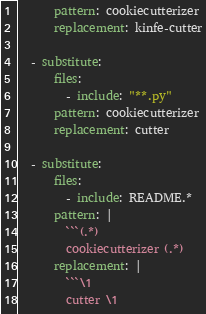Convert code to text. <code><loc_0><loc_0><loc_500><loc_500><_YAML_>      pattern: cookiecutterizer
      replacement: kinfe-cutter

  - substitute:
      files:
        - include: "**.py"
      pattern: cookiecutterizer
      replacement: cutter

  - substitute:
      files:
        - include: README.*
      pattern: |
        ```(.*)
        cookiecutterizer (.*)
      replacement: |
        ```\1
        cutter \1
</code> 